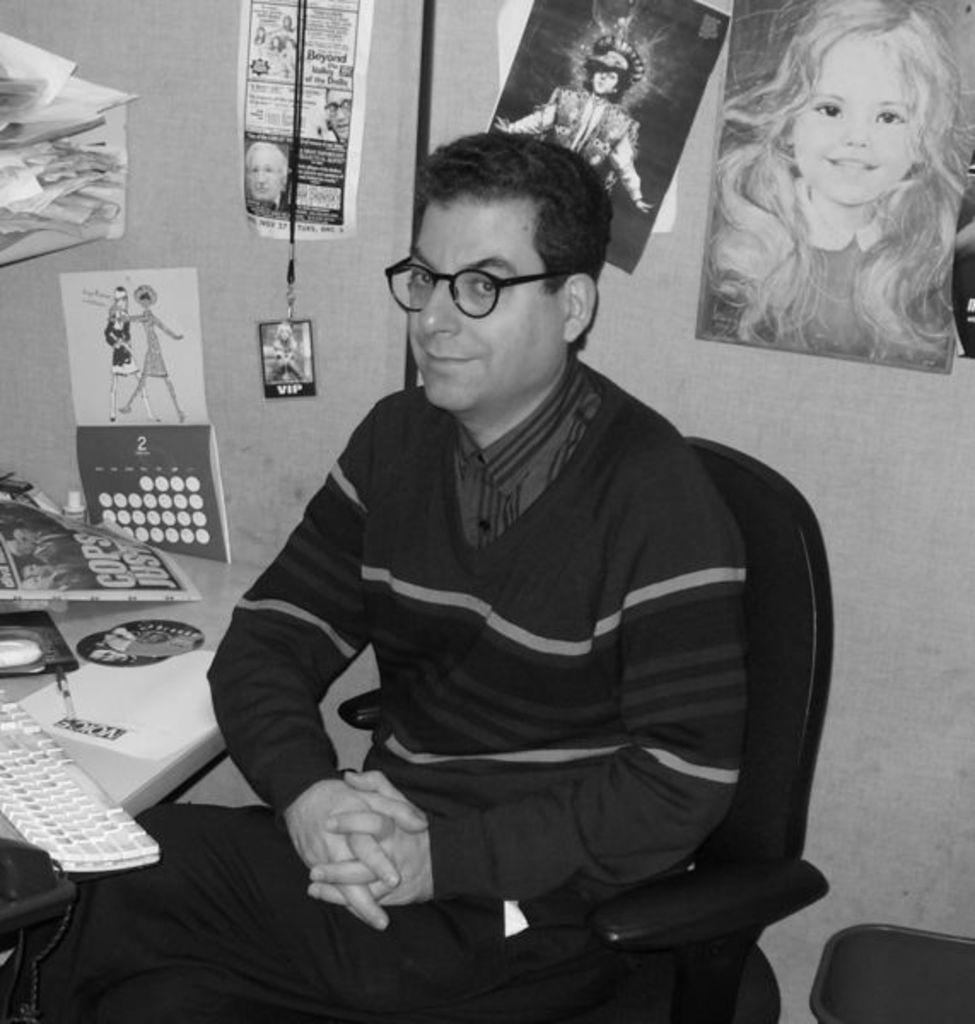What is the person in the image doing? The person is sitting on a chair. What can be seen on the wall in the image? Posters, an ID card, and pictures are present on the wall. What is on the table in the image? There is a keyboard on the table, as well as a poster and other things. What is located beside the person in the image? There is a bin beside the person. What type of crayon is the monkey using to talk in the image? There is no monkey or crayon present in the image, and therefore no such activity can be observed. 